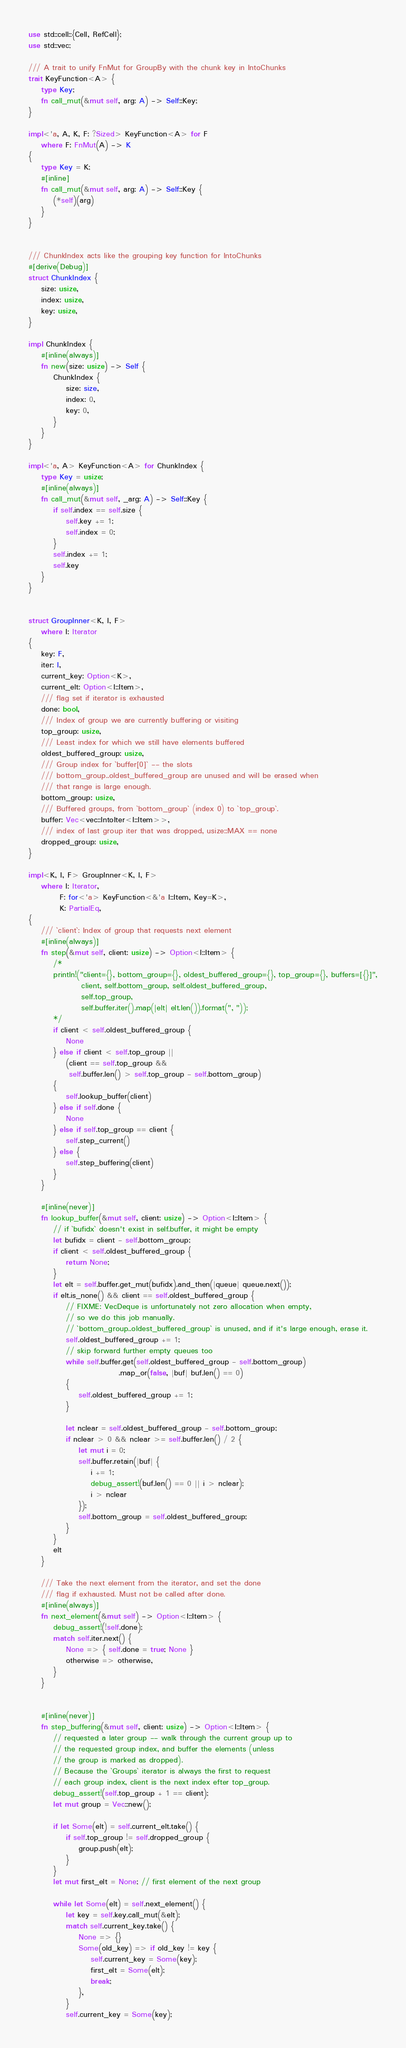Convert code to text. <code><loc_0><loc_0><loc_500><loc_500><_Rust_>use std::cell::{Cell, RefCell};
use std::vec;

/// A trait to unify FnMut for GroupBy with the chunk key in IntoChunks
trait KeyFunction<A> {
    type Key;
    fn call_mut(&mut self, arg: A) -> Self::Key;
}

impl<'a, A, K, F: ?Sized> KeyFunction<A> for F
    where F: FnMut(A) -> K
{
    type Key = K;
    #[inline]
    fn call_mut(&mut self, arg: A) -> Self::Key {
        (*self)(arg)
    }
}


/// ChunkIndex acts like the grouping key function for IntoChunks
#[derive(Debug)]
struct ChunkIndex {
    size: usize,
    index: usize,
    key: usize,
}

impl ChunkIndex {
    #[inline(always)]
    fn new(size: usize) -> Self {
        ChunkIndex {
            size: size,
            index: 0,
            key: 0,
        }
    }
}

impl<'a, A> KeyFunction<A> for ChunkIndex {
    type Key = usize;
    #[inline(always)]
    fn call_mut(&mut self, _arg: A) -> Self::Key {
        if self.index == self.size {
            self.key += 1;
            self.index = 0;
        }
        self.index += 1;
        self.key
    }
}


struct GroupInner<K, I, F>
    where I: Iterator
{
    key: F,
    iter: I,
    current_key: Option<K>,
    current_elt: Option<I::Item>,
    /// flag set if iterator is exhausted
    done: bool,
    /// Index of group we are currently buffering or visiting
    top_group: usize,
    /// Least index for which we still have elements buffered
    oldest_buffered_group: usize,
    /// Group index for `buffer[0]` -- the slots
    /// bottom_group..oldest_buffered_group are unused and will be erased when
    /// that range is large enough.
    bottom_group: usize,
    /// Buffered groups, from `bottom_group` (index 0) to `top_group`.
    buffer: Vec<vec::IntoIter<I::Item>>,
    /// index of last group iter that was dropped, usize::MAX == none
    dropped_group: usize,
}

impl<K, I, F> GroupInner<K, I, F>
    where I: Iterator,
          F: for<'a> KeyFunction<&'a I::Item, Key=K>,
          K: PartialEq,
{
    /// `client`: Index of group that requests next element
    #[inline(always)]
    fn step(&mut self, client: usize) -> Option<I::Item> {
        /*
        println!("client={}, bottom_group={}, oldest_buffered_group={}, top_group={}, buffers=[{}]",
                 client, self.bottom_group, self.oldest_buffered_group,
                 self.top_group,
                 self.buffer.iter().map(|elt| elt.len()).format(", "));
        */
        if client < self.oldest_buffered_group {
            None
        } else if client < self.top_group ||
            (client == self.top_group &&
             self.buffer.len() > self.top_group - self.bottom_group)
        {
            self.lookup_buffer(client)
        } else if self.done {
            None
        } else if self.top_group == client {
            self.step_current()
        } else {
            self.step_buffering(client)
        }
    }

    #[inline(never)]
    fn lookup_buffer(&mut self, client: usize) -> Option<I::Item> {
        // if `bufidx` doesn't exist in self.buffer, it might be empty
        let bufidx = client - self.bottom_group;
        if client < self.oldest_buffered_group {
            return None;
        }
        let elt = self.buffer.get_mut(bufidx).and_then(|queue| queue.next());
        if elt.is_none() && client == self.oldest_buffered_group {
            // FIXME: VecDeque is unfortunately not zero allocation when empty,
            // so we do this job manually.
            // `bottom_group..oldest_buffered_group` is unused, and if it's large enough, erase it.
            self.oldest_buffered_group += 1;
            // skip forward further empty queues too
            while self.buffer.get(self.oldest_buffered_group - self.bottom_group)
                             .map_or(false, |buf| buf.len() == 0)
            {
                self.oldest_buffered_group += 1;
            }

            let nclear = self.oldest_buffered_group - self.bottom_group;
            if nclear > 0 && nclear >= self.buffer.len() / 2 {
                let mut i = 0;
                self.buffer.retain(|buf| {
                    i += 1;
                    debug_assert!(buf.len() == 0 || i > nclear);
                    i > nclear
                });
                self.bottom_group = self.oldest_buffered_group;
            }
        }
        elt
    }

    /// Take the next element from the iterator, and set the done
    /// flag if exhausted. Must not be called after done.
    #[inline(always)]
    fn next_element(&mut self) -> Option<I::Item> {
        debug_assert!(!self.done);
        match self.iter.next() {
            None => { self.done = true; None }
            otherwise => otherwise,
        }
    }


    #[inline(never)]
    fn step_buffering(&mut self, client: usize) -> Option<I::Item> {
        // requested a later group -- walk through the current group up to
        // the requested group index, and buffer the elements (unless
        // the group is marked as dropped).
        // Because the `Groups` iterator is always the first to request
        // each group index, client is the next index efter top_group.
        debug_assert!(self.top_group + 1 == client);
        let mut group = Vec::new();

        if let Some(elt) = self.current_elt.take() {
            if self.top_group != self.dropped_group {
                group.push(elt);
            }
        }
        let mut first_elt = None; // first element of the next group

        while let Some(elt) = self.next_element() {
            let key = self.key.call_mut(&elt);
            match self.current_key.take() {
                None => {}
                Some(old_key) => if old_key != key {
                    self.current_key = Some(key);
                    first_elt = Some(elt);
                    break;
                },
            }
            self.current_key = Some(key);</code> 